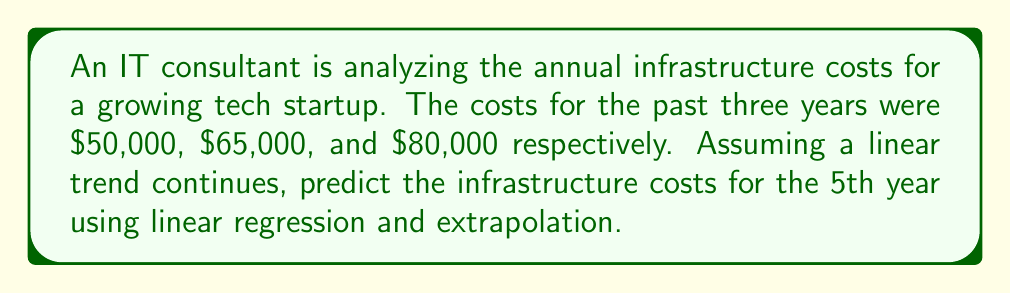Solve this math problem. Let's approach this step-by-step:

1) First, we need to set up our data points:
   Year 1: (1, 50000)
   Year 2: (2, 65000)
   Year 3: (3, 80000)

2) To perform linear regression, we'll use the formula:
   $$ y = mx + b $$
   where $m$ is the slope and $b$ is the y-intercept.

3) To find the slope $m$, we use:
   $$ m = \frac{\sum_{i=1}^{n} (x_i - \bar{x})(y_i - \bar{y})}{\sum_{i=1}^{n} (x_i - \bar{x})^2} $$

4) Calculate the means:
   $\bar{x} = \frac{1 + 2 + 3}{3} = 2$
   $\bar{y} = \frac{50000 + 65000 + 80000}{3} = 65000$

5) Calculate the numerator and denominator:
   Numerator: $(1-2)(50000-65000) + (2-2)(65000-65000) + (3-2)(80000-65000) = 15000$
   Denominator: $(1-2)^2 + (2-2)^2 + (3-2)^2 = 2$

6) Calculate the slope:
   $$ m = \frac{15000}{2} = 7500 $$

7) Use the point-slope form to find $b$:
   $65000 = 7500(2) + b$
   $b = 65000 - 15000 = 50000$

8) Our linear regression equation is:
   $$ y = 7500x + 50000 $$

9) To predict the 5th year, we extrapolate by plugging in $x = 5$:
   $$ y = 7500(5) + 50000 = 87500 $$

Therefore, the predicted infrastructure cost for the 5th year is $87,500.
Answer: $87,500 